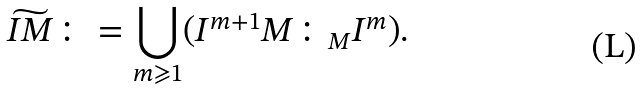<formula> <loc_0><loc_0><loc_500><loc_500>\widetilde { I M } \colon = \bigcup _ { m \geqslant 1 } ( I ^ { m + 1 } M \colon _ { M } I ^ { m } ) .</formula> 